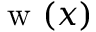<formula> <loc_0><loc_0><loc_500><loc_500>w ( x )</formula> 